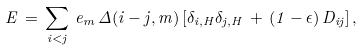<formula> <loc_0><loc_0><loc_500><loc_500>E \, = \, \sum _ { i < j } \, e _ { m } \, \Delta ( i - j , m ) \, [ \delta _ { i , H } \delta _ { j , H } \, + \, ( 1 - \epsilon ) \, D _ { i j } ] \, ,</formula> 